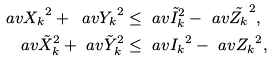<formula> <loc_0><loc_0><loc_500><loc_500>\ a v { X _ { k } } ^ { 2 } + \ a v { Y _ { k } } ^ { 2 } & \leq \ a v { \tilde { I } _ { k } } ^ { 2 } - \ a v { \tilde { Z _ { k } } } ^ { 2 } , \\ \ a v { \tilde { X } _ { k } } ^ { 2 } + \ a v { \tilde { Y } _ { k } } ^ { 2 } & \leq \ a v { { I } _ { k } } ^ { 2 } - \ a v { Z _ { k } } ^ { 2 } ,</formula> 